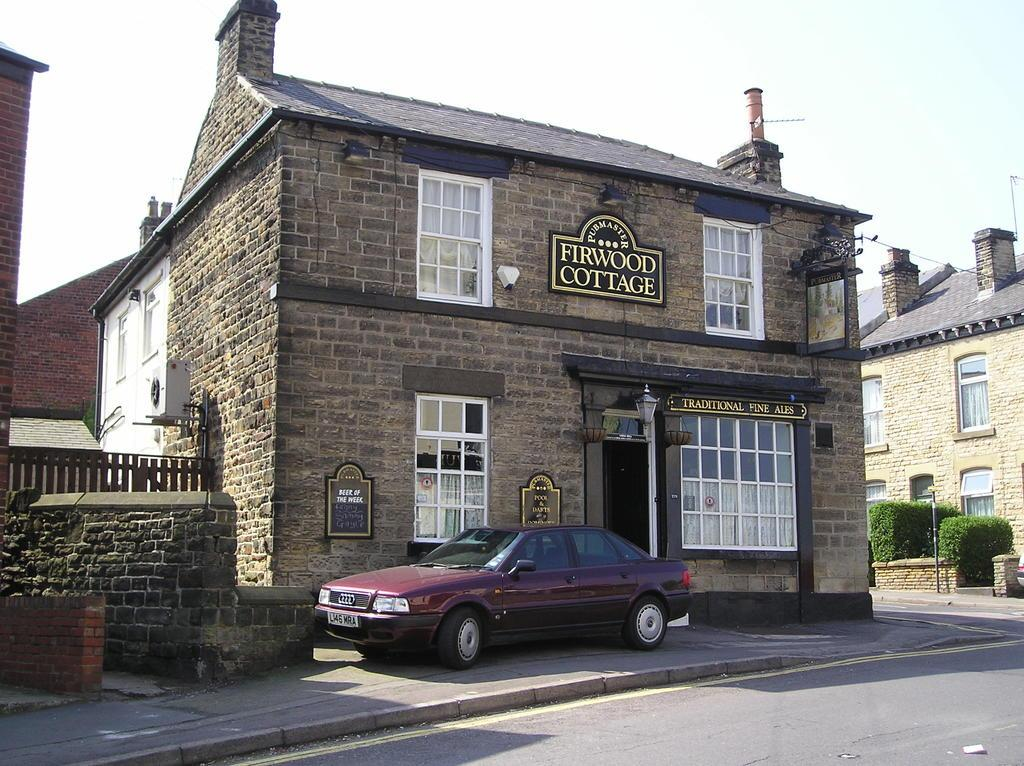What type of vehicle is on the ground in the image? The facts do not specify the type of vehicle, but there is a vehicle on the ground in the image. What additional object can be seen in the image? There is a lantern in the image. What structure is present in the image? There is a pole in the image. What type of vegetation is in the image? There are plants in the image. What type of man-made structures are visible in the image? There are buildings in the image. What is visible in the background of the image? The sky is visible in the background of the image. How does the brush help the plants grow in the image? There is no brush present in the image, so it cannot help the plants grow. What is the height of the low structure in the image? There is no mention of a low structure in the image, so we cannot determine its height. 